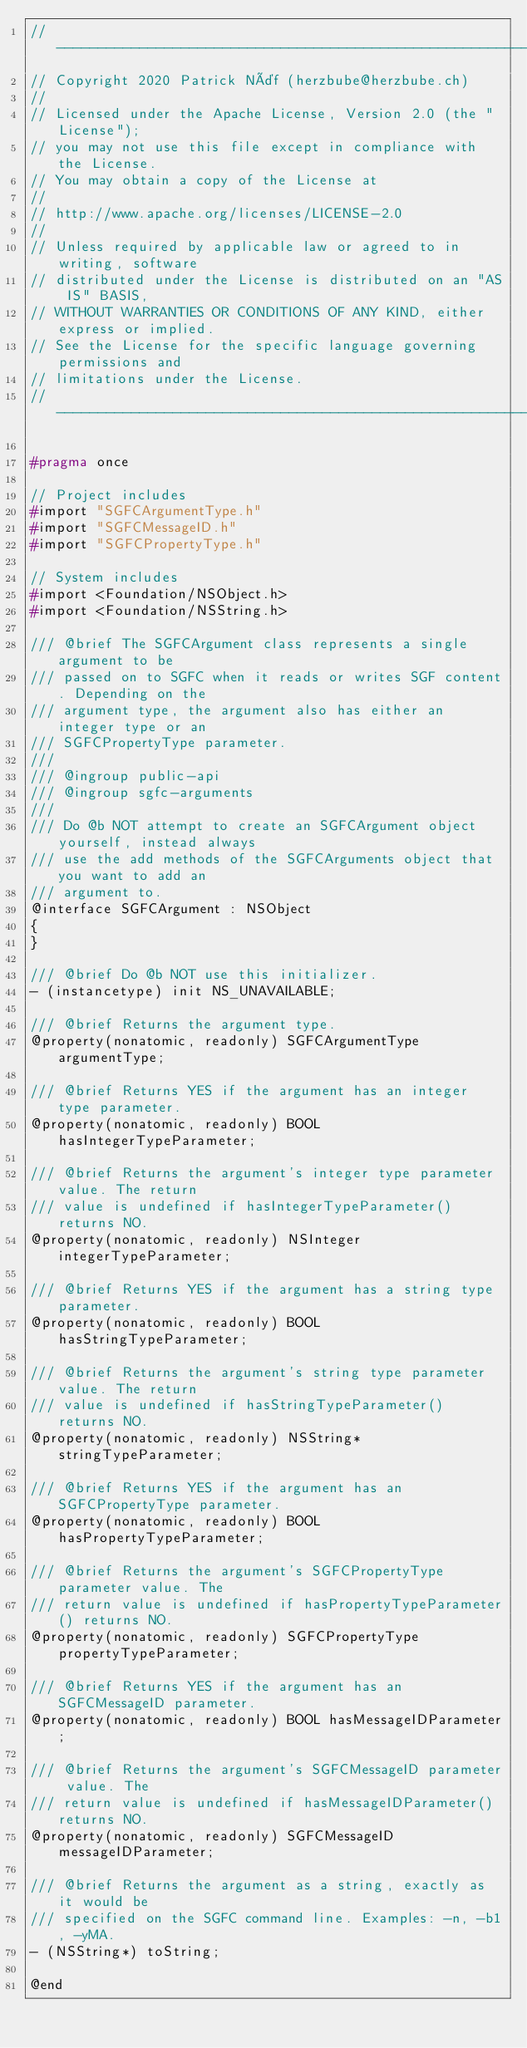<code> <loc_0><loc_0><loc_500><loc_500><_C_>// -----------------------------------------------------------------------------
// Copyright 2020 Patrick Näf (herzbube@herzbube.ch)
//
// Licensed under the Apache License, Version 2.0 (the "License");
// you may not use this file except in compliance with the License.
// You may obtain a copy of the License at
//
// http://www.apache.org/licenses/LICENSE-2.0
//
// Unless required by applicable law or agreed to in writing, software
// distributed under the License is distributed on an "AS IS" BASIS,
// WITHOUT WARRANTIES OR CONDITIONS OF ANY KIND, either express or implied.
// See the License for the specific language governing permissions and
// limitations under the License.
// -----------------------------------------------------------------------------

#pragma once

// Project includes
#import "SGFCArgumentType.h"
#import "SGFCMessageID.h"
#import "SGFCPropertyType.h"

// System includes
#import <Foundation/NSObject.h>
#import <Foundation/NSString.h>

/// @brief The SGFCArgument class represents a single argument to be
/// passed on to SGFC when it reads or writes SGF content. Depending on the
/// argument type, the argument also has either an integer type or an
/// SGFCPropertyType parameter.
///
/// @ingroup public-api
/// @ingroup sgfc-arguments
///
/// Do @b NOT attempt to create an SGFCArgument object yourself, instead always
/// use the add methods of the SGFCArguments object that you want to add an
/// argument to.
@interface SGFCArgument : NSObject
{
}

/// @brief Do @b NOT use this initializer.
- (instancetype) init NS_UNAVAILABLE;

/// @brief Returns the argument type.
@property(nonatomic, readonly) SGFCArgumentType argumentType;

/// @brief Returns YES if the argument has an integer type parameter.
@property(nonatomic, readonly) BOOL hasIntegerTypeParameter;

/// @brief Returns the argument's integer type parameter value. The return
/// value is undefined if hasIntegerTypeParameter() returns NO.
@property(nonatomic, readonly) NSInteger integerTypeParameter;

/// @brief Returns YES if the argument has a string type parameter.
@property(nonatomic, readonly) BOOL hasStringTypeParameter;

/// @brief Returns the argument's string type parameter value. The return
/// value is undefined if hasStringTypeParameter() returns NO.
@property(nonatomic, readonly) NSString* stringTypeParameter;

/// @brief Returns YES if the argument has an SGFCPropertyType parameter.
@property(nonatomic, readonly) BOOL hasPropertyTypeParameter;

/// @brief Returns the argument's SGFCPropertyType parameter value. The
/// return value is undefined if hasPropertyTypeParameter() returns NO.
@property(nonatomic, readonly) SGFCPropertyType propertyTypeParameter;

/// @brief Returns YES if the argument has an SGFCMessageID parameter.
@property(nonatomic, readonly) BOOL hasMessageIDParameter;

/// @brief Returns the argument's SGFCMessageID parameter value. The
/// return value is undefined if hasMessageIDParameter() returns NO.
@property(nonatomic, readonly) SGFCMessageID messageIDParameter;

/// @brief Returns the argument as a string, exactly as it would be
/// specified on the SGFC command line. Examples: -n, -b1, -yMA.
- (NSString*) toString;

@end
</code> 